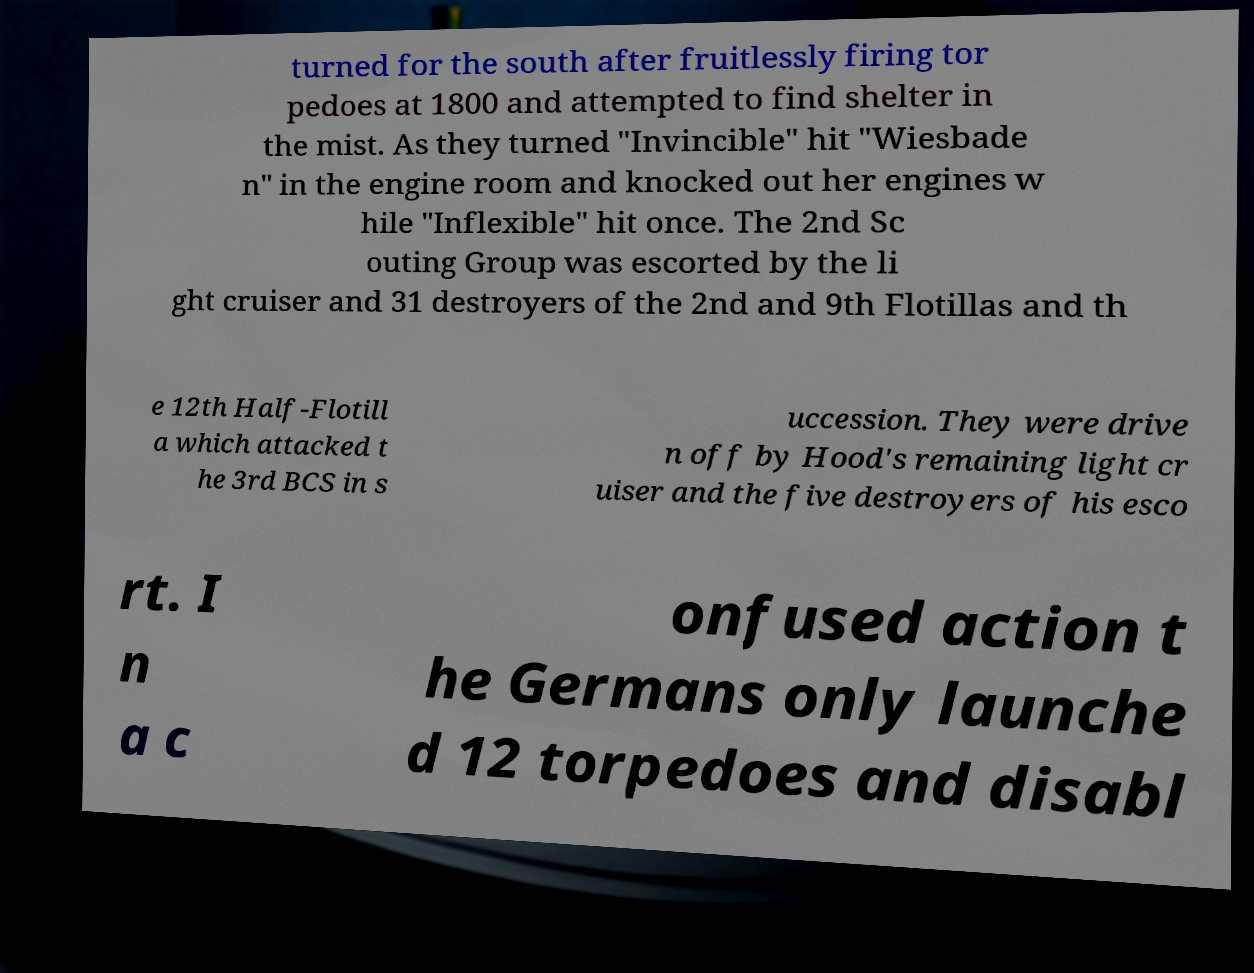Can you accurately transcribe the text from the provided image for me? turned for the south after fruitlessly firing tor pedoes at 1800 and attempted to find shelter in the mist. As they turned "Invincible" hit "Wiesbade n" in the engine room and knocked out her engines w hile "Inflexible" hit once. The 2nd Sc outing Group was escorted by the li ght cruiser and 31 destroyers of the 2nd and 9th Flotillas and th e 12th Half-Flotill a which attacked t he 3rd BCS in s uccession. They were drive n off by Hood's remaining light cr uiser and the five destroyers of his esco rt. I n a c onfused action t he Germans only launche d 12 torpedoes and disabl 